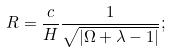Convert formula to latex. <formula><loc_0><loc_0><loc_500><loc_500>R = \frac { c } { H } \frac { 1 } { \sqrt { | \Omega + \lambda - 1 | } } ;</formula> 